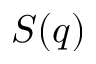<formula> <loc_0><loc_0><loc_500><loc_500>S ( q )</formula> 